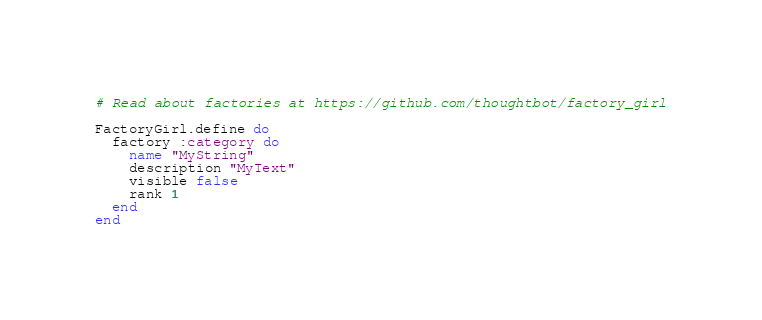<code> <loc_0><loc_0><loc_500><loc_500><_Ruby_># Read about factories at https://github.com/thoughtbot/factory_girl

FactoryGirl.define do
  factory :category do
    name "MyString"
    description "MyText"
    visible false
    rank 1
  end
end
</code> 